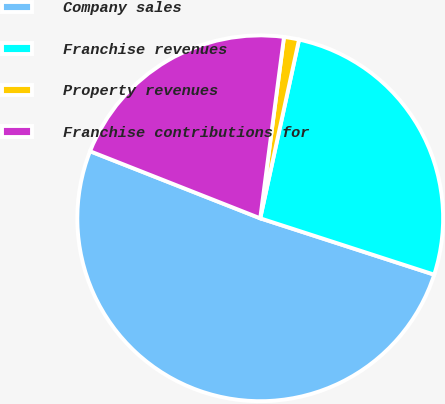<chart> <loc_0><loc_0><loc_500><loc_500><pie_chart><fcel>Company sales<fcel>Franchise revenues<fcel>Property revenues<fcel>Franchise contributions for<nl><fcel>50.99%<fcel>26.58%<fcel>1.33%<fcel>21.1%<nl></chart> 